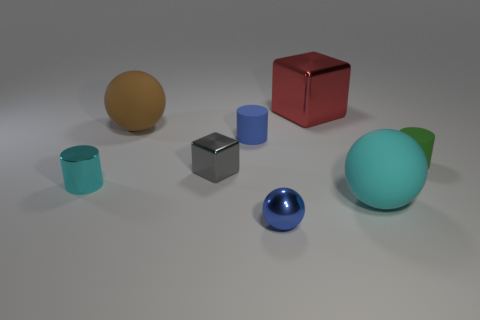Are there any other things of the same color as the small block?
Your answer should be very brief. No. What number of blue things are small cylinders or small shiny spheres?
Make the answer very short. 2. Is the number of cyan metal cylinders that are right of the tiny green matte cylinder less than the number of big brown matte objects?
Provide a succinct answer. Yes. There is a tiny blue metallic ball that is in front of the small cyan shiny thing; how many large things are behind it?
Provide a succinct answer. 3. What number of other objects are there of the same size as the brown matte ball?
Provide a succinct answer. 2. How many objects are either tiny gray shiny blocks or large matte balls right of the brown ball?
Your answer should be compact. 2. Are there fewer spheres than small things?
Offer a terse response. Yes. There is a tiny thing to the left of the large matte thing behind the small cyan metallic cylinder; what color is it?
Ensure brevity in your answer.  Cyan. There is a tiny green object that is the same shape as the cyan metal object; what is it made of?
Give a very brief answer. Rubber. How many rubber things are either cyan cylinders or brown blocks?
Ensure brevity in your answer.  0. 